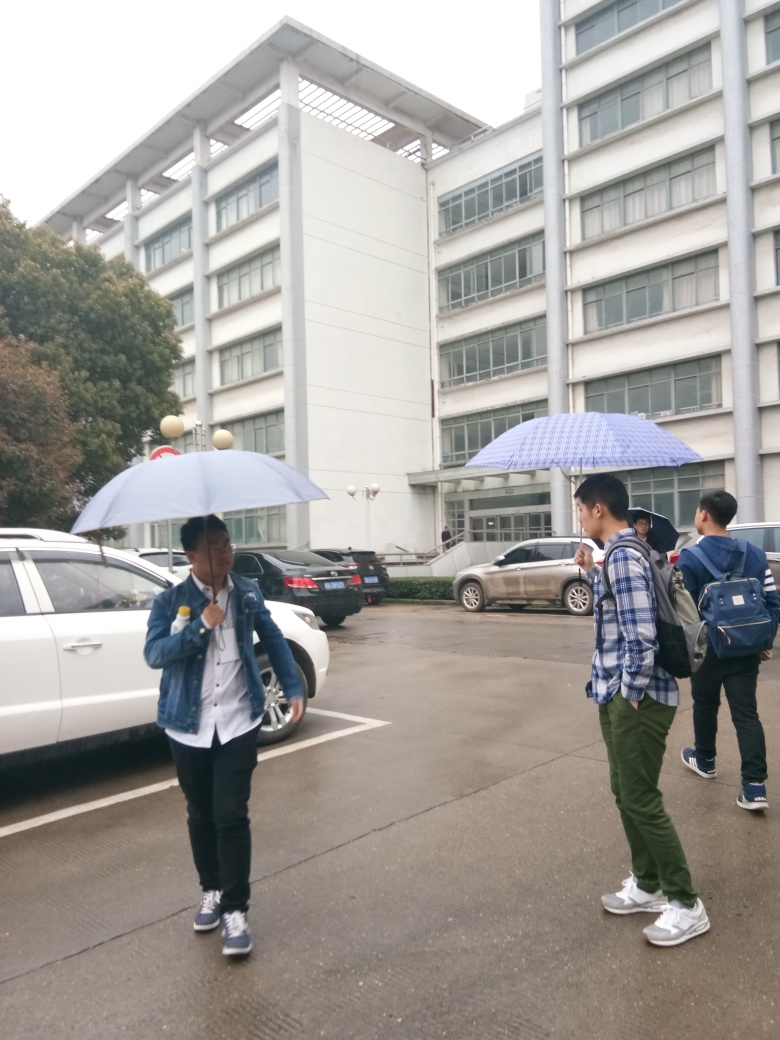Are there any particular emotions or moods conveyed by the people in this image? The individuals in the image seem to be going about their day in a very routine manner, without any distinct expressions of strong emotion. Their body language suggests a casual, perhaps slightly hurried pace, which is common for people navigating through wet conditions.  Can you tell me more about the setting of this image? The setting is an urban environment, likely a parking lot or a street adjacent to a large, multi-story building that looks institutional, possibly an office or a campus structure. The presence of several vehicles also supports the idea of it being a space where people might be commuting to or from work or school. 